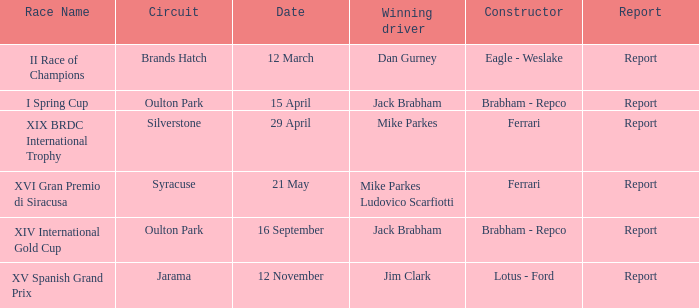What company constrcuted the vehicle with a circuit of oulton park on 15 april? Brabham - Repco. 